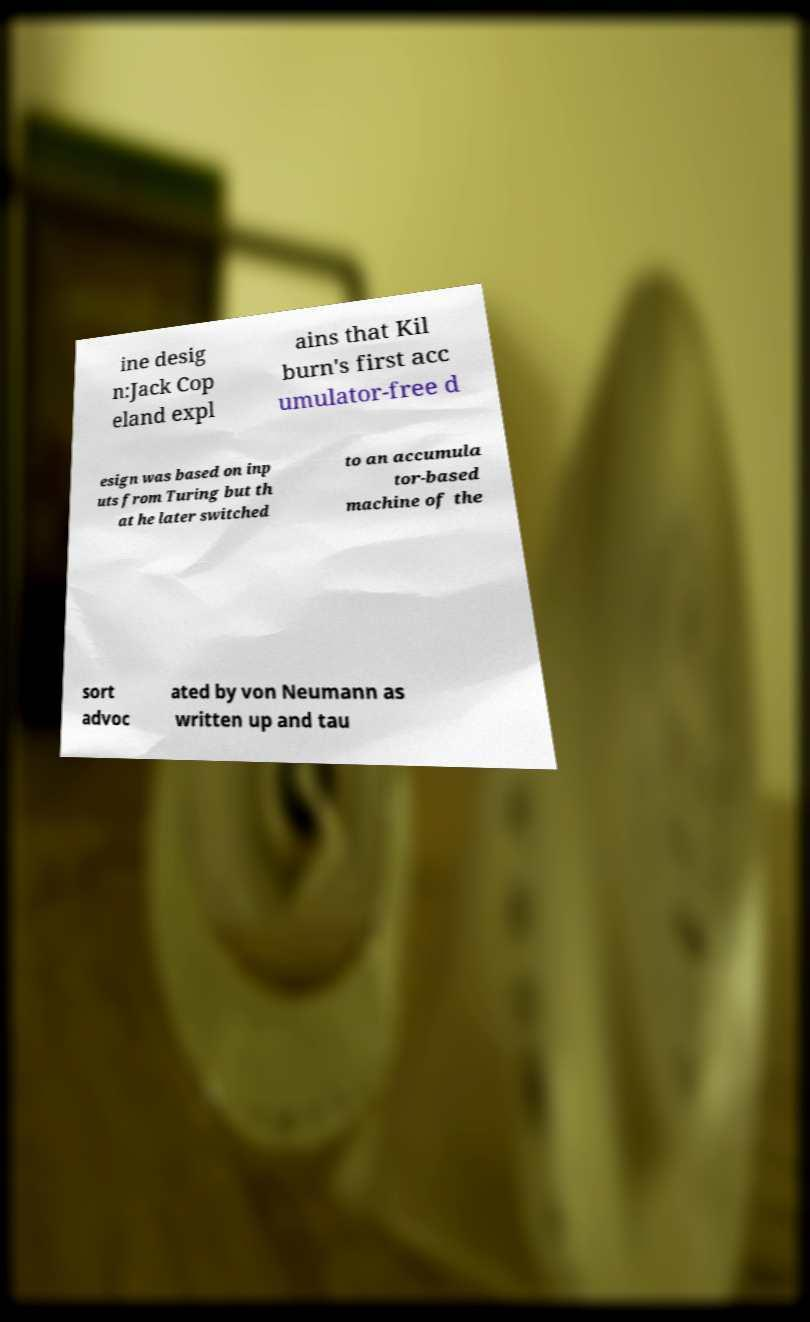Can you accurately transcribe the text from the provided image for me? ine desig n:Jack Cop eland expl ains that Kil burn's first acc umulator-free d esign was based on inp uts from Turing but th at he later switched to an accumula tor-based machine of the sort advoc ated by von Neumann as written up and tau 